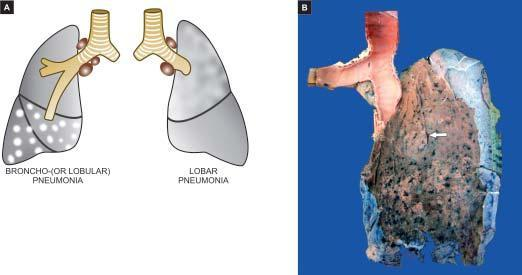s the shift of the curve to higher oxygen delivery spongy?
Answer the question using a single word or phrase. No 